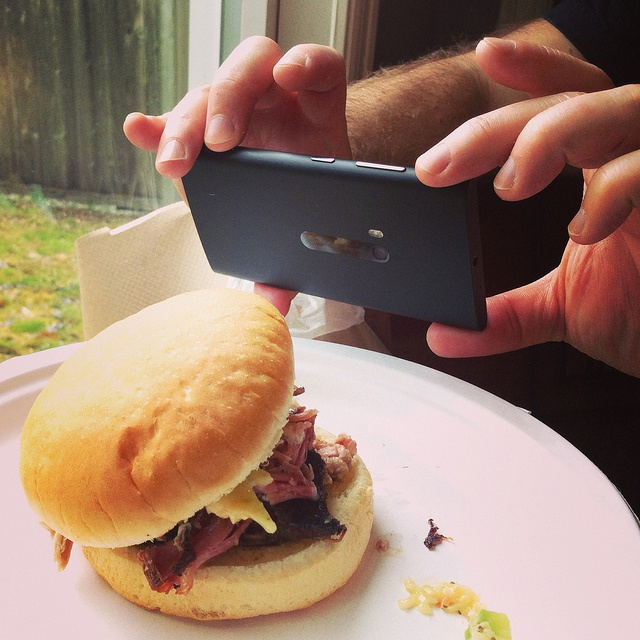Describe the objects in this image and their specific colors. I can see sandwich in black, tan, lightgray, and brown tones, people in black, maroon, brown, and tan tones, and cell phone in black and gray tones in this image. 